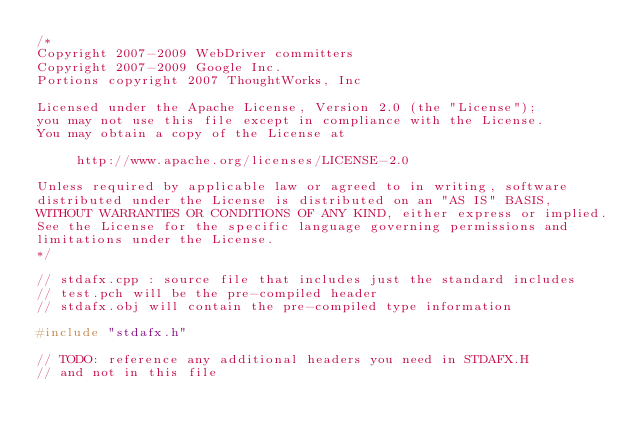<code> <loc_0><loc_0><loc_500><loc_500><_C++_>/*
Copyright 2007-2009 WebDriver committers
Copyright 2007-2009 Google Inc.
Portions copyright 2007 ThoughtWorks, Inc

Licensed under the Apache License, Version 2.0 (the "License");
you may not use this file except in compliance with the License.
You may obtain a copy of the License at

     http://www.apache.org/licenses/LICENSE-2.0

Unless required by applicable law or agreed to in writing, software
distributed under the License is distributed on an "AS IS" BASIS,
WITHOUT WARRANTIES OR CONDITIONS OF ANY KIND, either express or implied.
See the License for the specific language governing permissions and
limitations under the License.
*/

// stdafx.cpp : source file that includes just the standard includes
// test.pch will be the pre-compiled header
// stdafx.obj will contain the pre-compiled type information

#include "stdafx.h"

// TODO: reference any additional headers you need in STDAFX.H
// and not in this file
</code> 